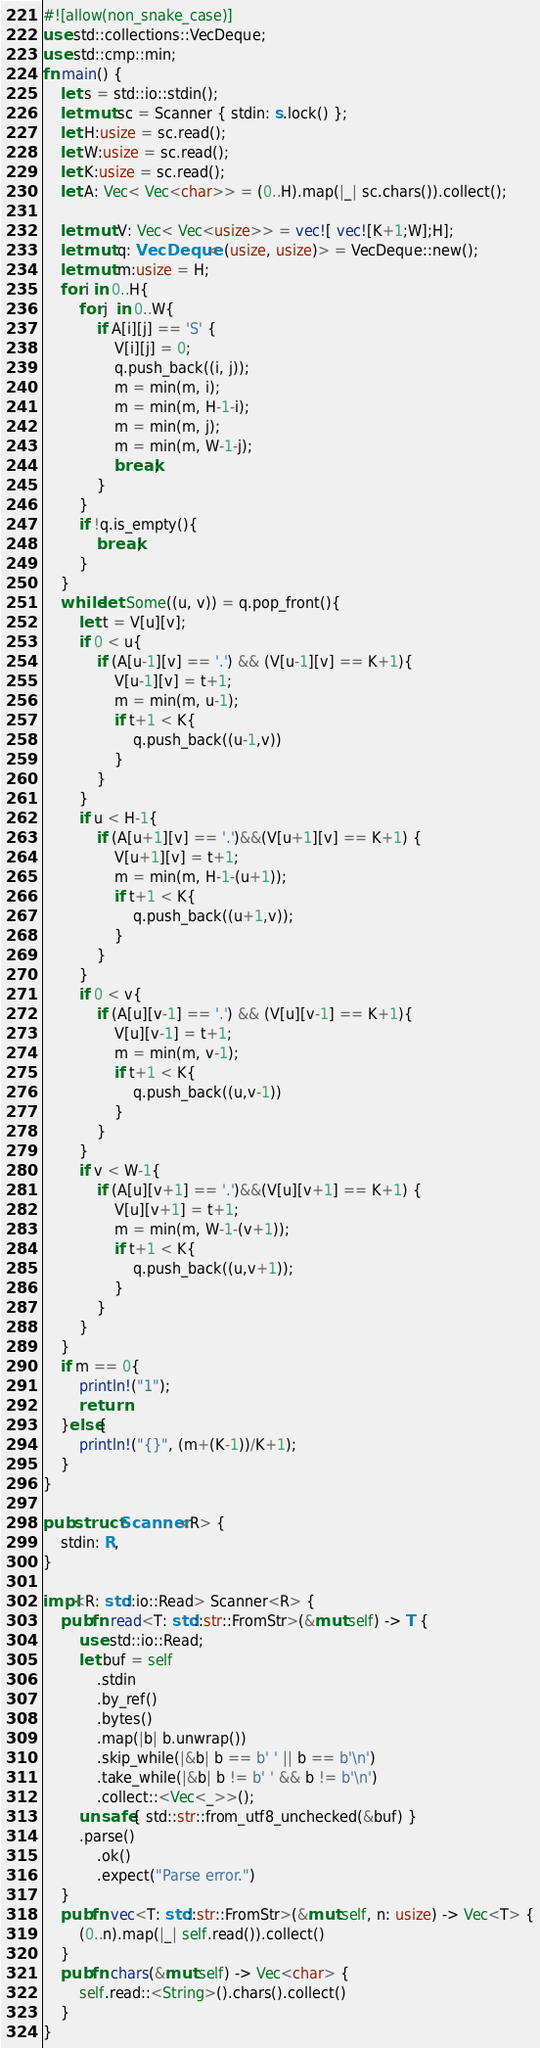<code> <loc_0><loc_0><loc_500><loc_500><_Rust_>#![allow(non_snake_case)]
use std::collections::VecDeque;
use std::cmp::min;
fn main() {
    let s = std::io::stdin();
    let mut sc = Scanner { stdin: s.lock() };
    let H:usize = sc.read();
    let W:usize = sc.read();
    let K:usize = sc.read();
    let A: Vec< Vec<char>> = (0..H).map(|_| sc.chars()).collect();

    let mut V: Vec< Vec<usize>> = vec![ vec![K+1;W];H];
    let mut q: VecDeque< (usize, usize)> = VecDeque::new();
    let mut m:usize = H;
    for i in 0..H{
        for j  in 0..W{
            if A[i][j] == 'S' {
                V[i][j] = 0;
                q.push_back((i, j));
                m = min(m, i);
                m = min(m, H-1-i);
                m = min(m, j);
                m = min(m, W-1-j); 
                break;
            }
        }
        if !q.is_empty(){
            break;
        }
    }
    while let Some((u, v)) = q.pop_front(){
        let t = V[u][v];
        if 0 < u{
            if (A[u-1][v] == '.') && (V[u-1][v] == K+1){
                V[u-1][v] = t+1;
                m = min(m, u-1);
                if t+1 < K{
                    q.push_back((u-1,v))
                }
            }
        }
        if u < H-1{
            if (A[u+1][v] == '.')&&(V[u+1][v] == K+1) {
                V[u+1][v] = t+1;
                m = min(m, H-1-(u+1));
                if t+1 < K{
                    q.push_back((u+1,v));
                }
            }
        }
        if 0 < v{
            if (A[u][v-1] == '.') && (V[u][v-1] == K+1){
                V[u][v-1] = t+1;
                m = min(m, v-1);
                if t+1 < K{
                    q.push_back((u,v-1))
                }
            }
        }
        if v < W-1{
            if (A[u][v+1] == '.')&&(V[u][v+1] == K+1) {
                V[u][v+1] = t+1;
                m = min(m, W-1-(v+1));
                if t+1 < K{
                    q.push_back((u,v+1));
                }
            }
        }
    }
    if m == 0{
        println!("1");
        return
    }else{
        println!("{}", (m+(K-1))/K+1);
    }
}

pub struct Scanner<R> {
    stdin: R,
}

impl<R: std::io::Read> Scanner<R> {
    pub fn read<T: std::str::FromStr>(&mut self) -> T {
        use std::io::Read;
        let buf = self
            .stdin
            .by_ref()
            .bytes()
            .map(|b| b.unwrap())
            .skip_while(|&b| b == b' ' || b == b'\n')
            .take_while(|&b| b != b' ' && b != b'\n')
            .collect::<Vec<_>>();
        unsafe { std::str::from_utf8_unchecked(&buf) }
        .parse()
            .ok()
            .expect("Parse error.")
    }
    pub fn vec<T: std::str::FromStr>(&mut self, n: usize) -> Vec<T> {
        (0..n).map(|_| self.read()).collect()
    }
    pub fn chars(&mut self) -> Vec<char> {
        self.read::<String>().chars().collect()
    }
}


</code> 